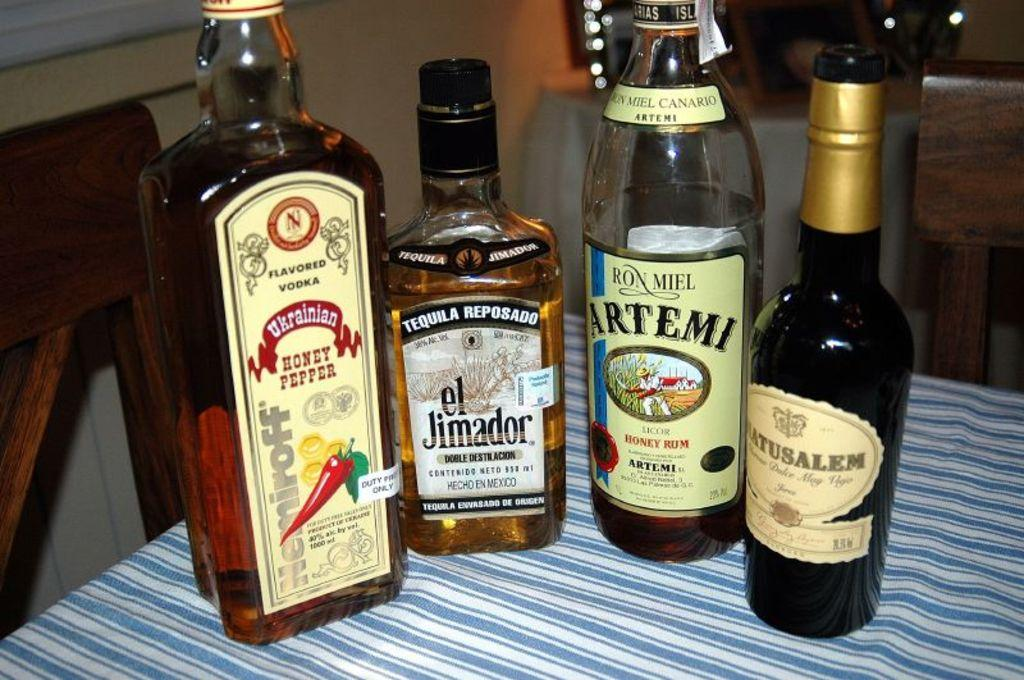Provide a one-sentence caption for the provided image. Four liquor bottles on a tablecloth, including Ukranian Honey Pepper flavored vodka, el Jimador Tequila Reposado, Ron Miel Artemi Honey Rum. 